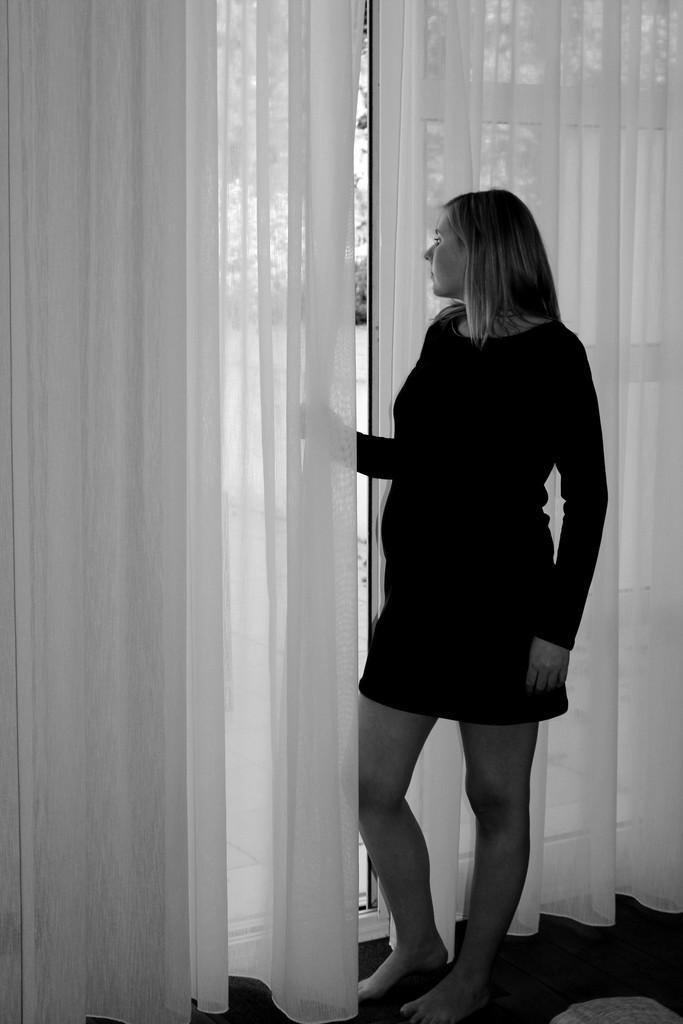Who is present in the image? There is a lady in the image. What is the lady doing in the image? The lady is standing near a window in the image. What can be seen on the window in the image? There are curtains visible on the window in the image. What type of toys can be seen on the edge of the window in the image? There are no toys present in the image, and the edge of the window is not mentioned in the provided facts. 